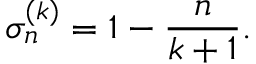<formula> <loc_0><loc_0><loc_500><loc_500>\sigma _ { n } ^ { ( k ) } = 1 - \frac { n } { k + 1 } .</formula> 